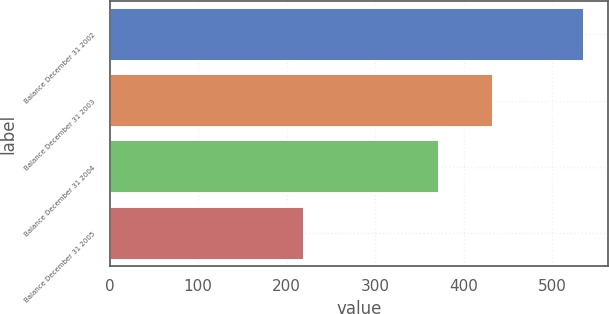Convert chart to OTSL. <chart><loc_0><loc_0><loc_500><loc_500><bar_chart><fcel>Balance December 31 2002<fcel>Balance December 31 2003<fcel>Balance December 31 2004<fcel>Balance December 31 2005<nl><fcel>536<fcel>433<fcel>372<fcel>220<nl></chart> 